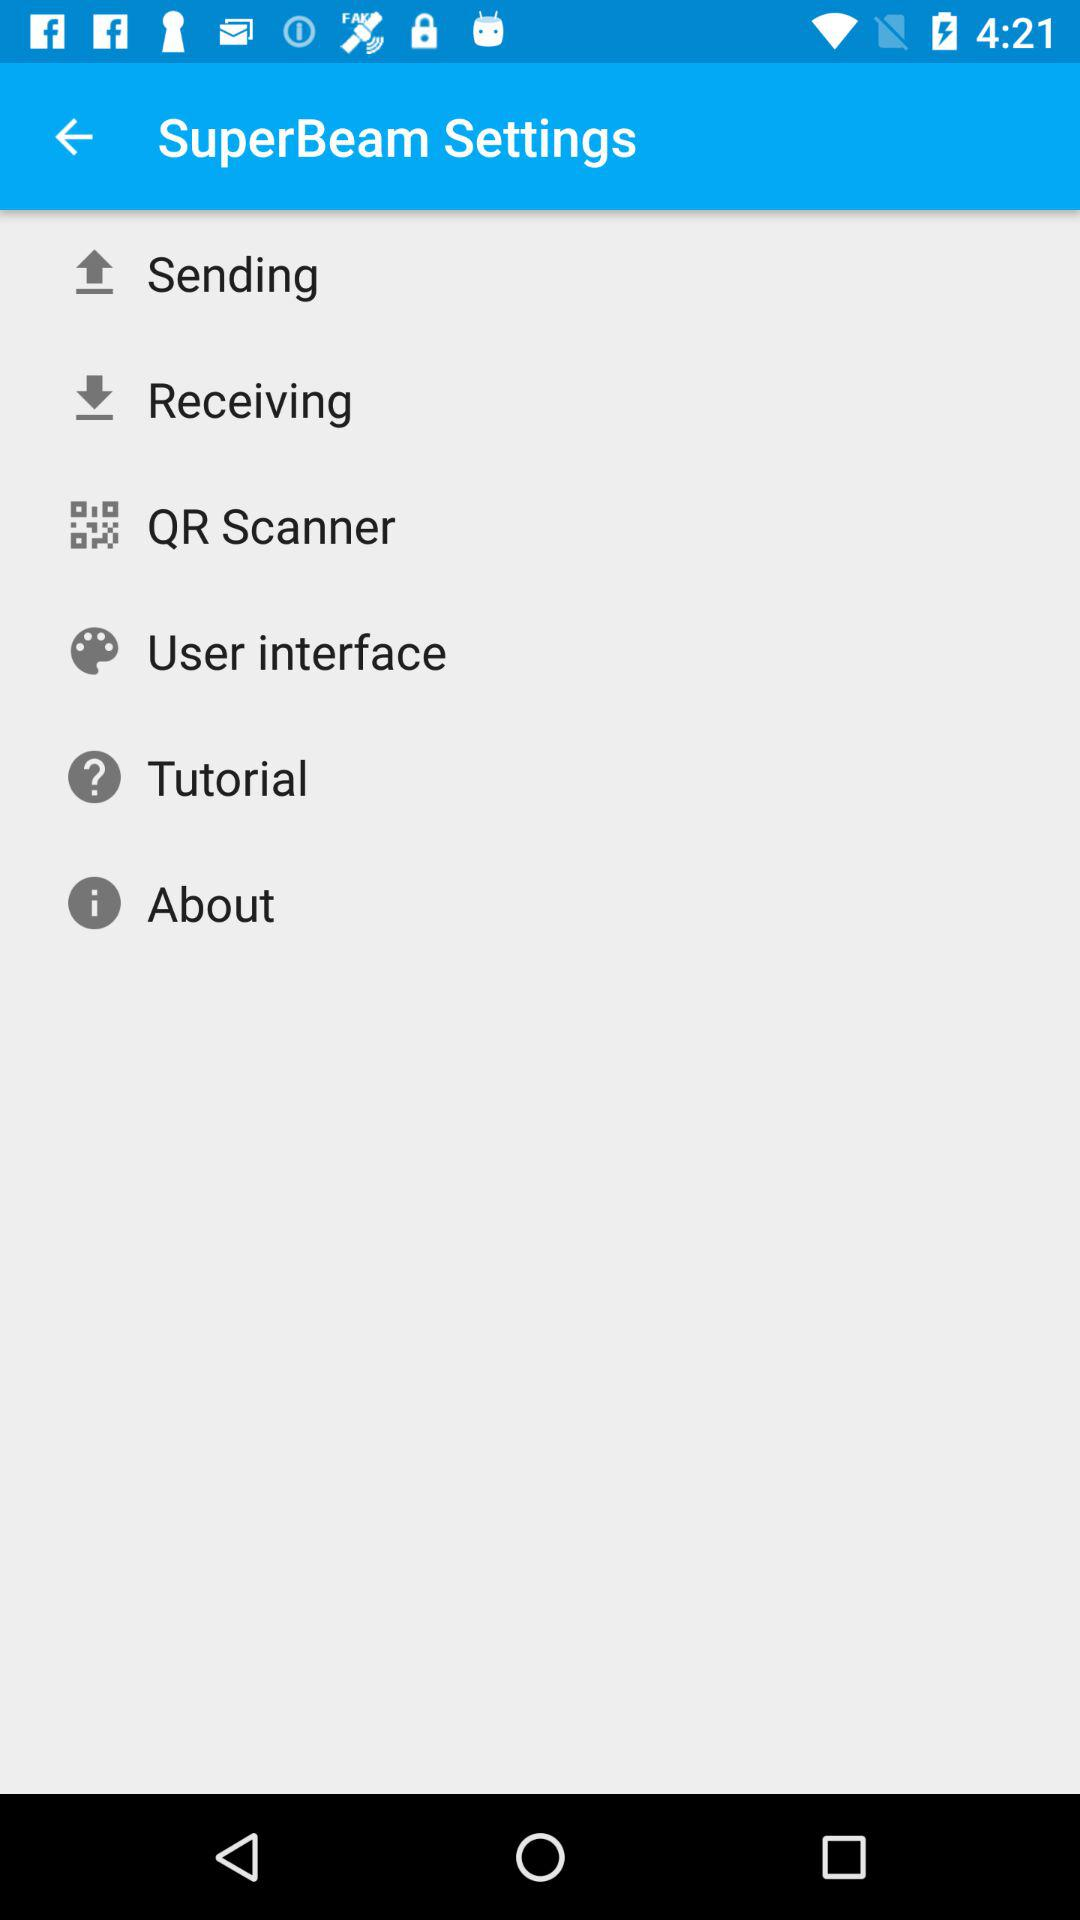How many items are in the Settings menu?
Answer the question using a single word or phrase. 6 